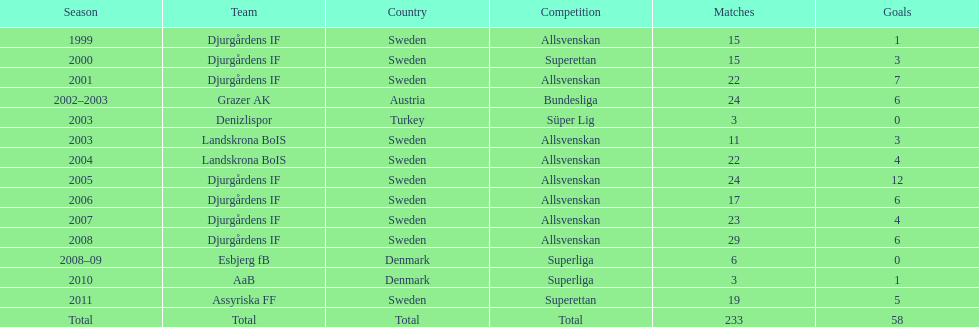What is the total number of goals scored by jones kusi-asare? 58. 